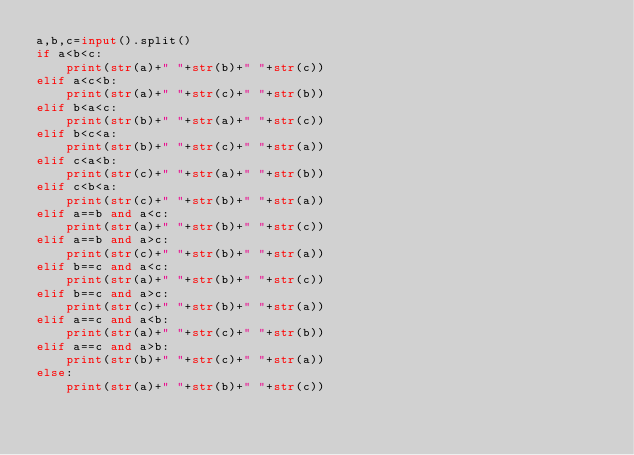<code> <loc_0><loc_0><loc_500><loc_500><_Python_>a,b,c=input().split()
if a<b<c:
    print(str(a)+" "+str(b)+" "+str(c))
elif a<c<b:
    print(str(a)+" "+str(c)+" "+str(b))
elif b<a<c:
    print(str(b)+" "+str(a)+" "+str(c))
elif b<c<a:
    print(str(b)+" "+str(c)+" "+str(a))
elif c<a<b:
    print(str(c)+" "+str(a)+" "+str(b))
elif c<b<a:
    print(str(c)+" "+str(b)+" "+str(a))
elif a==b and a<c:
    print(str(a)+" "+str(b)+" "+str(c)) 
elif a==b and a>c:
    print(str(c)+" "+str(b)+" "+str(a)) 
elif b==c and a<c:
    print(str(a)+" "+str(b)+" "+str(c)) 
elif b==c and a>c:
    print(str(c)+" "+str(b)+" "+str(a))
elif a==c and a<b:
    print(str(a)+" "+str(c)+" "+str(b))
elif a==c and a>b:
    print(str(b)+" "+str(c)+" "+str(a))
else:
    print(str(a)+" "+str(b)+" "+str(c))
</code> 